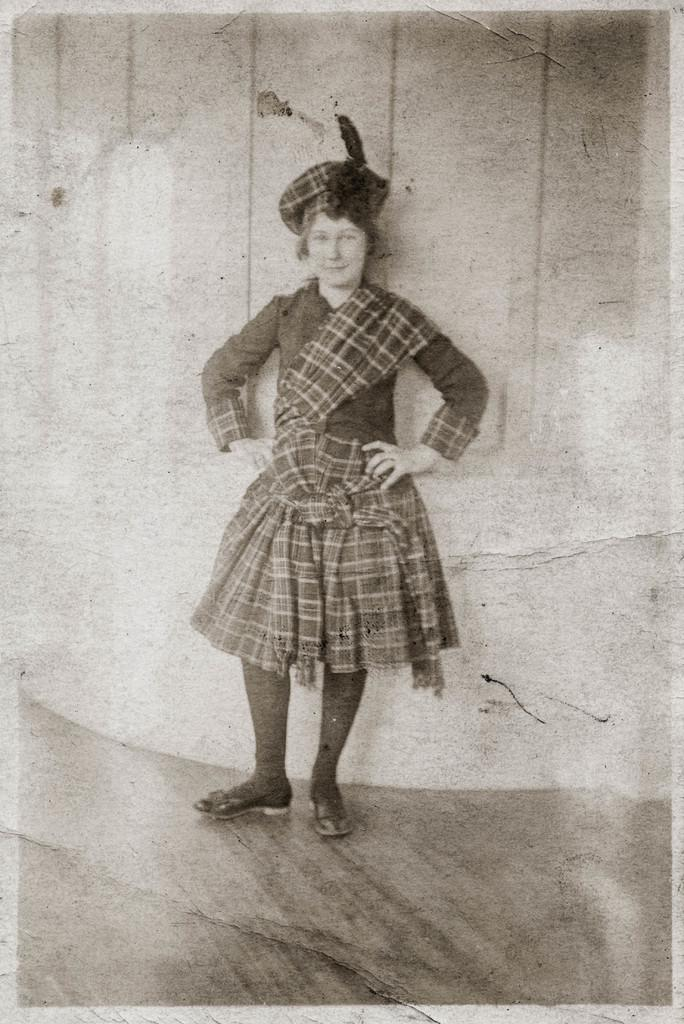Who is present in the image? There is a woman in the image. What is the woman doing in the image? The woman is standing on the floor. What can be seen in the background of the image? There is a wall in the background of the image. How many jellyfish are floating near the woman in the image? There are no jellyfish present in the image. What is the texture of the woman's chin in the image? The image does not provide enough detail to determine the texture of the woman's chin. 